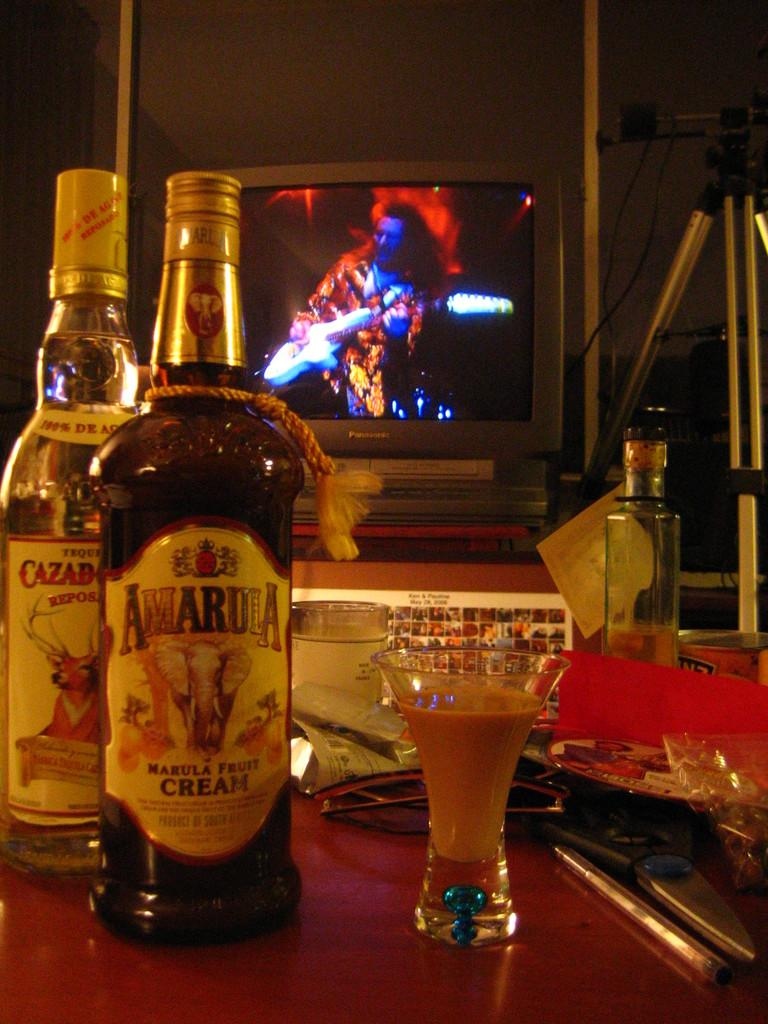<image>
Offer a succinct explanation of the picture presented. An unopened bottle of Amarula fruit cream next to a bottle of Tequila 